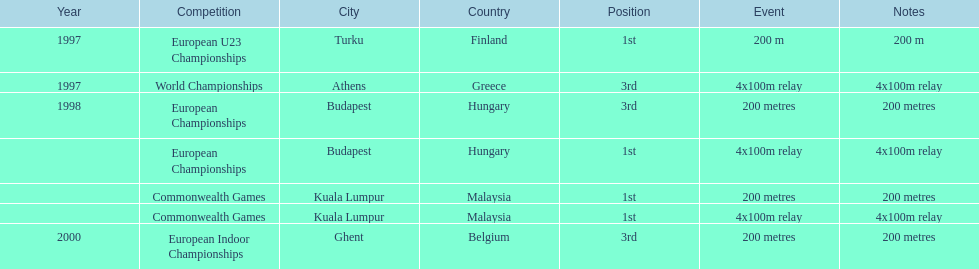What was the only event won in belgium? European Indoor Championships. 